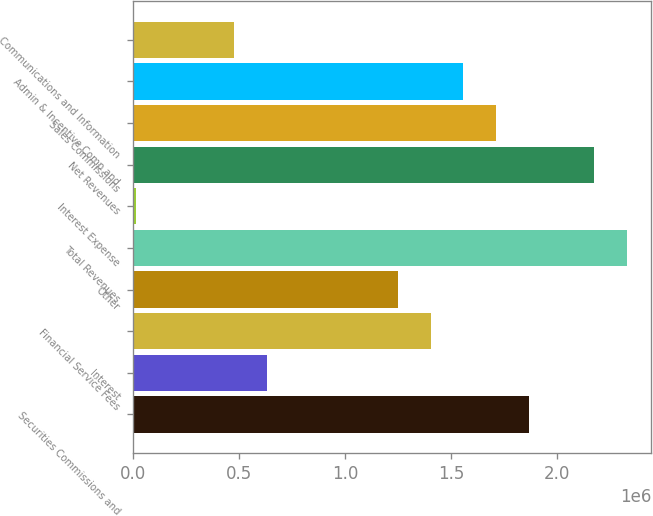Convert chart. <chart><loc_0><loc_0><loc_500><loc_500><bar_chart><fcel>Securities Commissions and<fcel>Interest<fcel>Financial Service Fees<fcel>Other<fcel>Total Revenues<fcel>Interest Expense<fcel>Net Revenues<fcel>Sales Commissions<fcel>Admin & Incentive Comp and<fcel>Communications and Information<nl><fcel>1.86598e+06<fcel>631919<fcel>1.4032e+06<fcel>1.24895e+06<fcel>2.32875e+06<fcel>14891<fcel>2.17449e+06<fcel>1.71172e+06<fcel>1.55746e+06<fcel>477662<nl></chart> 